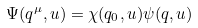<formula> <loc_0><loc_0><loc_500><loc_500>\Psi ( q ^ { \mu } , u ) = \chi ( q _ { 0 } , u ) \psi ( { q } , u )</formula> 